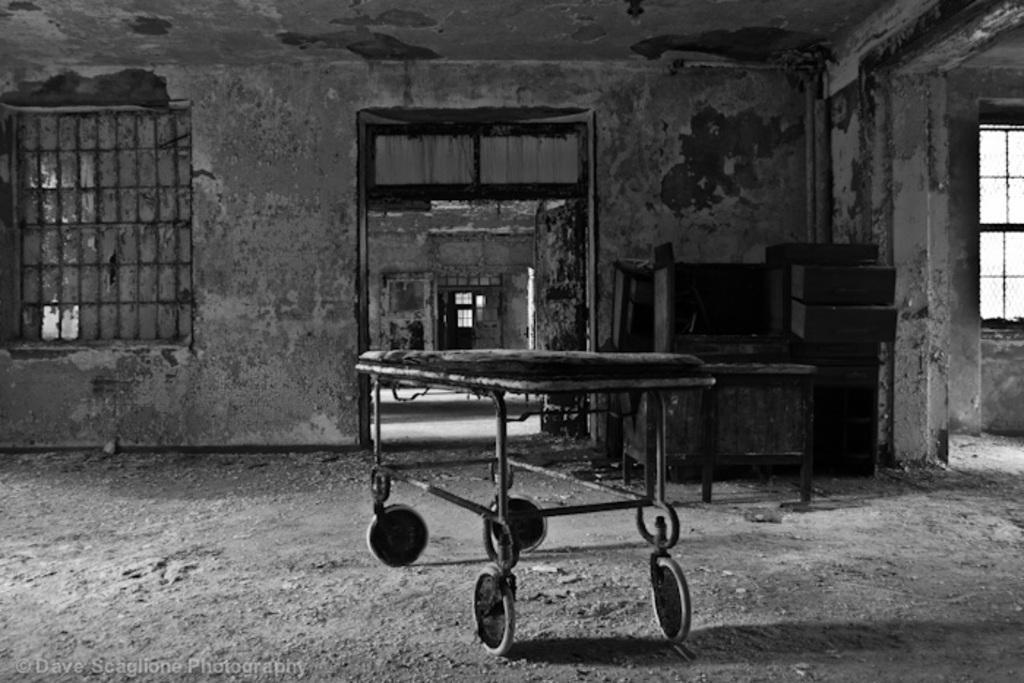Can you describe this image briefly? In the center of the image there is a trolley. On the right there is a table and we can see things placed on the table. There is a door and we can see windows. 